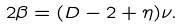Convert formula to latex. <formula><loc_0><loc_0><loc_500><loc_500>2 \beta = ( D - 2 + \eta ) \nu .</formula> 